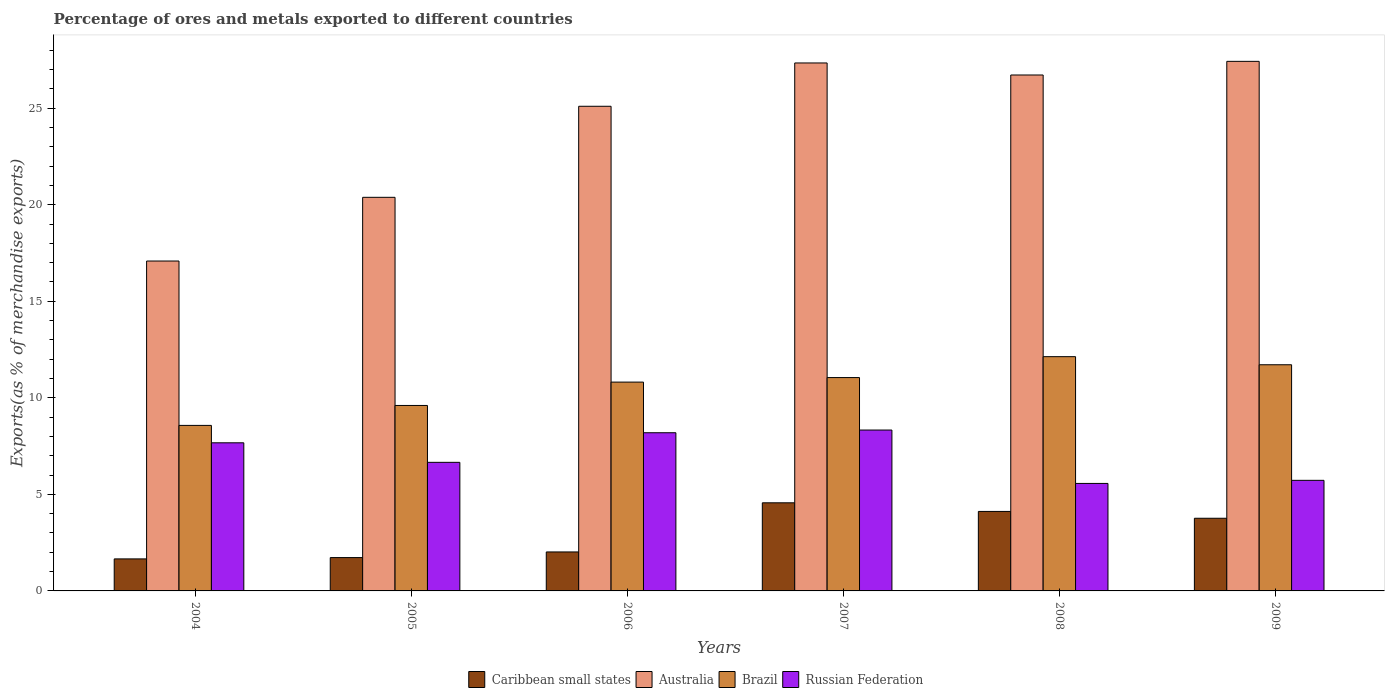How many different coloured bars are there?
Your answer should be compact. 4. Are the number of bars per tick equal to the number of legend labels?
Give a very brief answer. Yes. How many bars are there on the 5th tick from the right?
Ensure brevity in your answer.  4. What is the percentage of exports to different countries in Caribbean small states in 2008?
Make the answer very short. 4.12. Across all years, what is the maximum percentage of exports to different countries in Brazil?
Keep it short and to the point. 12.13. Across all years, what is the minimum percentage of exports to different countries in Russian Federation?
Provide a succinct answer. 5.57. In which year was the percentage of exports to different countries in Caribbean small states maximum?
Your answer should be compact. 2007. What is the total percentage of exports to different countries in Russian Federation in the graph?
Offer a terse response. 42.15. What is the difference between the percentage of exports to different countries in Australia in 2007 and that in 2009?
Your response must be concise. -0.08. What is the difference between the percentage of exports to different countries in Brazil in 2007 and the percentage of exports to different countries in Australia in 2006?
Give a very brief answer. -14.05. What is the average percentage of exports to different countries in Brazil per year?
Provide a short and direct response. 10.65. In the year 2009, what is the difference between the percentage of exports to different countries in Russian Federation and percentage of exports to different countries in Brazil?
Your answer should be very brief. -5.99. What is the ratio of the percentage of exports to different countries in Brazil in 2005 to that in 2007?
Your answer should be very brief. 0.87. Is the percentage of exports to different countries in Brazil in 2004 less than that in 2005?
Ensure brevity in your answer.  Yes. What is the difference between the highest and the second highest percentage of exports to different countries in Brazil?
Provide a short and direct response. 0.42. What is the difference between the highest and the lowest percentage of exports to different countries in Russian Federation?
Keep it short and to the point. 2.77. In how many years, is the percentage of exports to different countries in Caribbean small states greater than the average percentage of exports to different countries in Caribbean small states taken over all years?
Your answer should be very brief. 3. Is it the case that in every year, the sum of the percentage of exports to different countries in Russian Federation and percentage of exports to different countries in Brazil is greater than the sum of percentage of exports to different countries in Australia and percentage of exports to different countries in Caribbean small states?
Your answer should be very brief. No. What does the 1st bar from the left in 2006 represents?
Give a very brief answer. Caribbean small states. What does the 1st bar from the right in 2006 represents?
Give a very brief answer. Russian Federation. How many years are there in the graph?
Keep it short and to the point. 6. How are the legend labels stacked?
Your answer should be compact. Horizontal. What is the title of the graph?
Your answer should be compact. Percentage of ores and metals exported to different countries. What is the label or title of the Y-axis?
Ensure brevity in your answer.  Exports(as % of merchandise exports). What is the Exports(as % of merchandise exports) in Caribbean small states in 2004?
Provide a short and direct response. 1.66. What is the Exports(as % of merchandise exports) of Australia in 2004?
Your answer should be compact. 17.09. What is the Exports(as % of merchandise exports) in Brazil in 2004?
Provide a succinct answer. 8.57. What is the Exports(as % of merchandise exports) of Russian Federation in 2004?
Provide a succinct answer. 7.67. What is the Exports(as % of merchandise exports) in Caribbean small states in 2005?
Give a very brief answer. 1.73. What is the Exports(as % of merchandise exports) of Australia in 2005?
Your answer should be very brief. 20.38. What is the Exports(as % of merchandise exports) in Brazil in 2005?
Give a very brief answer. 9.61. What is the Exports(as % of merchandise exports) in Russian Federation in 2005?
Ensure brevity in your answer.  6.66. What is the Exports(as % of merchandise exports) in Caribbean small states in 2006?
Give a very brief answer. 2.02. What is the Exports(as % of merchandise exports) of Australia in 2006?
Make the answer very short. 25.1. What is the Exports(as % of merchandise exports) of Brazil in 2006?
Your response must be concise. 10.81. What is the Exports(as % of merchandise exports) of Russian Federation in 2006?
Offer a terse response. 8.19. What is the Exports(as % of merchandise exports) of Caribbean small states in 2007?
Offer a terse response. 4.56. What is the Exports(as % of merchandise exports) in Australia in 2007?
Keep it short and to the point. 27.34. What is the Exports(as % of merchandise exports) of Brazil in 2007?
Offer a very short reply. 11.05. What is the Exports(as % of merchandise exports) of Russian Federation in 2007?
Give a very brief answer. 8.33. What is the Exports(as % of merchandise exports) of Caribbean small states in 2008?
Provide a short and direct response. 4.12. What is the Exports(as % of merchandise exports) of Australia in 2008?
Keep it short and to the point. 26.72. What is the Exports(as % of merchandise exports) of Brazil in 2008?
Make the answer very short. 12.13. What is the Exports(as % of merchandise exports) in Russian Federation in 2008?
Provide a short and direct response. 5.57. What is the Exports(as % of merchandise exports) in Caribbean small states in 2009?
Your answer should be compact. 3.76. What is the Exports(as % of merchandise exports) of Australia in 2009?
Keep it short and to the point. 27.43. What is the Exports(as % of merchandise exports) in Brazil in 2009?
Your answer should be very brief. 11.71. What is the Exports(as % of merchandise exports) in Russian Federation in 2009?
Your response must be concise. 5.73. Across all years, what is the maximum Exports(as % of merchandise exports) in Caribbean small states?
Ensure brevity in your answer.  4.56. Across all years, what is the maximum Exports(as % of merchandise exports) in Australia?
Make the answer very short. 27.43. Across all years, what is the maximum Exports(as % of merchandise exports) of Brazil?
Keep it short and to the point. 12.13. Across all years, what is the maximum Exports(as % of merchandise exports) of Russian Federation?
Provide a short and direct response. 8.33. Across all years, what is the minimum Exports(as % of merchandise exports) in Caribbean small states?
Offer a very short reply. 1.66. Across all years, what is the minimum Exports(as % of merchandise exports) in Australia?
Give a very brief answer. 17.09. Across all years, what is the minimum Exports(as % of merchandise exports) of Brazil?
Provide a short and direct response. 8.57. Across all years, what is the minimum Exports(as % of merchandise exports) in Russian Federation?
Offer a terse response. 5.57. What is the total Exports(as % of merchandise exports) of Caribbean small states in the graph?
Give a very brief answer. 17.85. What is the total Exports(as % of merchandise exports) in Australia in the graph?
Ensure brevity in your answer.  144.06. What is the total Exports(as % of merchandise exports) in Brazil in the graph?
Offer a terse response. 63.89. What is the total Exports(as % of merchandise exports) in Russian Federation in the graph?
Provide a succinct answer. 42.15. What is the difference between the Exports(as % of merchandise exports) of Caribbean small states in 2004 and that in 2005?
Provide a succinct answer. -0.07. What is the difference between the Exports(as % of merchandise exports) of Australia in 2004 and that in 2005?
Give a very brief answer. -3.3. What is the difference between the Exports(as % of merchandise exports) of Brazil in 2004 and that in 2005?
Give a very brief answer. -1.03. What is the difference between the Exports(as % of merchandise exports) in Russian Federation in 2004 and that in 2005?
Your response must be concise. 1.01. What is the difference between the Exports(as % of merchandise exports) in Caribbean small states in 2004 and that in 2006?
Your answer should be very brief. -0.36. What is the difference between the Exports(as % of merchandise exports) of Australia in 2004 and that in 2006?
Make the answer very short. -8.01. What is the difference between the Exports(as % of merchandise exports) in Brazil in 2004 and that in 2006?
Your answer should be very brief. -2.24. What is the difference between the Exports(as % of merchandise exports) in Russian Federation in 2004 and that in 2006?
Keep it short and to the point. -0.52. What is the difference between the Exports(as % of merchandise exports) of Caribbean small states in 2004 and that in 2007?
Your response must be concise. -2.9. What is the difference between the Exports(as % of merchandise exports) of Australia in 2004 and that in 2007?
Your answer should be compact. -10.26. What is the difference between the Exports(as % of merchandise exports) in Brazil in 2004 and that in 2007?
Provide a succinct answer. -2.48. What is the difference between the Exports(as % of merchandise exports) of Russian Federation in 2004 and that in 2007?
Your answer should be very brief. -0.66. What is the difference between the Exports(as % of merchandise exports) in Caribbean small states in 2004 and that in 2008?
Provide a short and direct response. -2.46. What is the difference between the Exports(as % of merchandise exports) of Australia in 2004 and that in 2008?
Your answer should be compact. -9.63. What is the difference between the Exports(as % of merchandise exports) of Brazil in 2004 and that in 2008?
Give a very brief answer. -3.56. What is the difference between the Exports(as % of merchandise exports) in Russian Federation in 2004 and that in 2008?
Provide a short and direct response. 2.1. What is the difference between the Exports(as % of merchandise exports) in Caribbean small states in 2004 and that in 2009?
Keep it short and to the point. -2.1. What is the difference between the Exports(as % of merchandise exports) in Australia in 2004 and that in 2009?
Give a very brief answer. -10.34. What is the difference between the Exports(as % of merchandise exports) of Brazil in 2004 and that in 2009?
Your response must be concise. -3.14. What is the difference between the Exports(as % of merchandise exports) in Russian Federation in 2004 and that in 2009?
Offer a terse response. 1.94. What is the difference between the Exports(as % of merchandise exports) in Caribbean small states in 2005 and that in 2006?
Offer a very short reply. -0.29. What is the difference between the Exports(as % of merchandise exports) of Australia in 2005 and that in 2006?
Your answer should be very brief. -4.72. What is the difference between the Exports(as % of merchandise exports) of Brazil in 2005 and that in 2006?
Give a very brief answer. -1.21. What is the difference between the Exports(as % of merchandise exports) in Russian Federation in 2005 and that in 2006?
Make the answer very short. -1.53. What is the difference between the Exports(as % of merchandise exports) in Caribbean small states in 2005 and that in 2007?
Provide a short and direct response. -2.84. What is the difference between the Exports(as % of merchandise exports) of Australia in 2005 and that in 2007?
Make the answer very short. -6.96. What is the difference between the Exports(as % of merchandise exports) in Brazil in 2005 and that in 2007?
Your answer should be compact. -1.44. What is the difference between the Exports(as % of merchandise exports) in Russian Federation in 2005 and that in 2007?
Your answer should be compact. -1.67. What is the difference between the Exports(as % of merchandise exports) of Caribbean small states in 2005 and that in 2008?
Your answer should be very brief. -2.39. What is the difference between the Exports(as % of merchandise exports) in Australia in 2005 and that in 2008?
Give a very brief answer. -6.34. What is the difference between the Exports(as % of merchandise exports) of Brazil in 2005 and that in 2008?
Offer a terse response. -2.53. What is the difference between the Exports(as % of merchandise exports) in Russian Federation in 2005 and that in 2008?
Make the answer very short. 1.09. What is the difference between the Exports(as % of merchandise exports) of Caribbean small states in 2005 and that in 2009?
Provide a succinct answer. -2.04. What is the difference between the Exports(as % of merchandise exports) in Australia in 2005 and that in 2009?
Your response must be concise. -7.04. What is the difference between the Exports(as % of merchandise exports) of Brazil in 2005 and that in 2009?
Keep it short and to the point. -2.11. What is the difference between the Exports(as % of merchandise exports) of Russian Federation in 2005 and that in 2009?
Offer a terse response. 0.93. What is the difference between the Exports(as % of merchandise exports) in Caribbean small states in 2006 and that in 2007?
Provide a succinct answer. -2.54. What is the difference between the Exports(as % of merchandise exports) of Australia in 2006 and that in 2007?
Your answer should be very brief. -2.24. What is the difference between the Exports(as % of merchandise exports) in Brazil in 2006 and that in 2007?
Provide a succinct answer. -0.23. What is the difference between the Exports(as % of merchandise exports) of Russian Federation in 2006 and that in 2007?
Your answer should be very brief. -0.14. What is the difference between the Exports(as % of merchandise exports) of Caribbean small states in 2006 and that in 2008?
Offer a terse response. -2.1. What is the difference between the Exports(as % of merchandise exports) in Australia in 2006 and that in 2008?
Make the answer very short. -1.62. What is the difference between the Exports(as % of merchandise exports) of Brazil in 2006 and that in 2008?
Your answer should be very brief. -1.32. What is the difference between the Exports(as % of merchandise exports) of Russian Federation in 2006 and that in 2008?
Provide a succinct answer. 2.63. What is the difference between the Exports(as % of merchandise exports) in Caribbean small states in 2006 and that in 2009?
Make the answer very short. -1.74. What is the difference between the Exports(as % of merchandise exports) of Australia in 2006 and that in 2009?
Provide a short and direct response. -2.33. What is the difference between the Exports(as % of merchandise exports) in Brazil in 2006 and that in 2009?
Keep it short and to the point. -0.9. What is the difference between the Exports(as % of merchandise exports) in Russian Federation in 2006 and that in 2009?
Offer a very short reply. 2.46. What is the difference between the Exports(as % of merchandise exports) in Caribbean small states in 2007 and that in 2008?
Give a very brief answer. 0.45. What is the difference between the Exports(as % of merchandise exports) in Australia in 2007 and that in 2008?
Your answer should be very brief. 0.62. What is the difference between the Exports(as % of merchandise exports) of Brazil in 2007 and that in 2008?
Make the answer very short. -1.08. What is the difference between the Exports(as % of merchandise exports) in Russian Federation in 2007 and that in 2008?
Your answer should be very brief. 2.77. What is the difference between the Exports(as % of merchandise exports) in Caribbean small states in 2007 and that in 2009?
Make the answer very short. 0.8. What is the difference between the Exports(as % of merchandise exports) in Australia in 2007 and that in 2009?
Your answer should be very brief. -0.08. What is the difference between the Exports(as % of merchandise exports) of Brazil in 2007 and that in 2009?
Provide a short and direct response. -0.66. What is the difference between the Exports(as % of merchandise exports) in Russian Federation in 2007 and that in 2009?
Give a very brief answer. 2.6. What is the difference between the Exports(as % of merchandise exports) in Caribbean small states in 2008 and that in 2009?
Offer a very short reply. 0.35. What is the difference between the Exports(as % of merchandise exports) in Australia in 2008 and that in 2009?
Provide a succinct answer. -0.71. What is the difference between the Exports(as % of merchandise exports) of Brazil in 2008 and that in 2009?
Provide a succinct answer. 0.42. What is the difference between the Exports(as % of merchandise exports) of Russian Federation in 2008 and that in 2009?
Ensure brevity in your answer.  -0.16. What is the difference between the Exports(as % of merchandise exports) in Caribbean small states in 2004 and the Exports(as % of merchandise exports) in Australia in 2005?
Offer a very short reply. -18.73. What is the difference between the Exports(as % of merchandise exports) of Caribbean small states in 2004 and the Exports(as % of merchandise exports) of Brazil in 2005?
Offer a terse response. -7.95. What is the difference between the Exports(as % of merchandise exports) of Caribbean small states in 2004 and the Exports(as % of merchandise exports) of Russian Federation in 2005?
Keep it short and to the point. -5. What is the difference between the Exports(as % of merchandise exports) of Australia in 2004 and the Exports(as % of merchandise exports) of Brazil in 2005?
Your answer should be compact. 7.48. What is the difference between the Exports(as % of merchandise exports) of Australia in 2004 and the Exports(as % of merchandise exports) of Russian Federation in 2005?
Offer a terse response. 10.43. What is the difference between the Exports(as % of merchandise exports) in Brazil in 2004 and the Exports(as % of merchandise exports) in Russian Federation in 2005?
Your answer should be very brief. 1.91. What is the difference between the Exports(as % of merchandise exports) of Caribbean small states in 2004 and the Exports(as % of merchandise exports) of Australia in 2006?
Provide a short and direct response. -23.44. What is the difference between the Exports(as % of merchandise exports) of Caribbean small states in 2004 and the Exports(as % of merchandise exports) of Brazil in 2006?
Your response must be concise. -9.16. What is the difference between the Exports(as % of merchandise exports) of Caribbean small states in 2004 and the Exports(as % of merchandise exports) of Russian Federation in 2006?
Your response must be concise. -6.53. What is the difference between the Exports(as % of merchandise exports) in Australia in 2004 and the Exports(as % of merchandise exports) in Brazil in 2006?
Offer a terse response. 6.27. What is the difference between the Exports(as % of merchandise exports) of Australia in 2004 and the Exports(as % of merchandise exports) of Russian Federation in 2006?
Provide a succinct answer. 8.89. What is the difference between the Exports(as % of merchandise exports) of Brazil in 2004 and the Exports(as % of merchandise exports) of Russian Federation in 2006?
Your answer should be compact. 0.38. What is the difference between the Exports(as % of merchandise exports) of Caribbean small states in 2004 and the Exports(as % of merchandise exports) of Australia in 2007?
Keep it short and to the point. -25.68. What is the difference between the Exports(as % of merchandise exports) of Caribbean small states in 2004 and the Exports(as % of merchandise exports) of Brazil in 2007?
Keep it short and to the point. -9.39. What is the difference between the Exports(as % of merchandise exports) of Caribbean small states in 2004 and the Exports(as % of merchandise exports) of Russian Federation in 2007?
Your answer should be compact. -6.67. What is the difference between the Exports(as % of merchandise exports) of Australia in 2004 and the Exports(as % of merchandise exports) of Brazil in 2007?
Your answer should be compact. 6.04. What is the difference between the Exports(as % of merchandise exports) of Australia in 2004 and the Exports(as % of merchandise exports) of Russian Federation in 2007?
Your answer should be compact. 8.75. What is the difference between the Exports(as % of merchandise exports) of Brazil in 2004 and the Exports(as % of merchandise exports) of Russian Federation in 2007?
Ensure brevity in your answer.  0.24. What is the difference between the Exports(as % of merchandise exports) in Caribbean small states in 2004 and the Exports(as % of merchandise exports) in Australia in 2008?
Your answer should be very brief. -25.06. What is the difference between the Exports(as % of merchandise exports) of Caribbean small states in 2004 and the Exports(as % of merchandise exports) of Brazil in 2008?
Your answer should be compact. -10.47. What is the difference between the Exports(as % of merchandise exports) of Caribbean small states in 2004 and the Exports(as % of merchandise exports) of Russian Federation in 2008?
Give a very brief answer. -3.91. What is the difference between the Exports(as % of merchandise exports) in Australia in 2004 and the Exports(as % of merchandise exports) in Brazil in 2008?
Your answer should be very brief. 4.95. What is the difference between the Exports(as % of merchandise exports) of Australia in 2004 and the Exports(as % of merchandise exports) of Russian Federation in 2008?
Provide a succinct answer. 11.52. What is the difference between the Exports(as % of merchandise exports) of Brazil in 2004 and the Exports(as % of merchandise exports) of Russian Federation in 2008?
Keep it short and to the point. 3.01. What is the difference between the Exports(as % of merchandise exports) of Caribbean small states in 2004 and the Exports(as % of merchandise exports) of Australia in 2009?
Make the answer very short. -25.77. What is the difference between the Exports(as % of merchandise exports) in Caribbean small states in 2004 and the Exports(as % of merchandise exports) in Brazil in 2009?
Your answer should be compact. -10.05. What is the difference between the Exports(as % of merchandise exports) of Caribbean small states in 2004 and the Exports(as % of merchandise exports) of Russian Federation in 2009?
Your response must be concise. -4.07. What is the difference between the Exports(as % of merchandise exports) of Australia in 2004 and the Exports(as % of merchandise exports) of Brazil in 2009?
Make the answer very short. 5.37. What is the difference between the Exports(as % of merchandise exports) of Australia in 2004 and the Exports(as % of merchandise exports) of Russian Federation in 2009?
Keep it short and to the point. 11.36. What is the difference between the Exports(as % of merchandise exports) of Brazil in 2004 and the Exports(as % of merchandise exports) of Russian Federation in 2009?
Offer a very short reply. 2.85. What is the difference between the Exports(as % of merchandise exports) of Caribbean small states in 2005 and the Exports(as % of merchandise exports) of Australia in 2006?
Provide a succinct answer. -23.37. What is the difference between the Exports(as % of merchandise exports) of Caribbean small states in 2005 and the Exports(as % of merchandise exports) of Brazil in 2006?
Offer a terse response. -9.09. What is the difference between the Exports(as % of merchandise exports) in Caribbean small states in 2005 and the Exports(as % of merchandise exports) in Russian Federation in 2006?
Provide a succinct answer. -6.47. What is the difference between the Exports(as % of merchandise exports) in Australia in 2005 and the Exports(as % of merchandise exports) in Brazil in 2006?
Offer a terse response. 9.57. What is the difference between the Exports(as % of merchandise exports) in Australia in 2005 and the Exports(as % of merchandise exports) in Russian Federation in 2006?
Provide a succinct answer. 12.19. What is the difference between the Exports(as % of merchandise exports) of Brazil in 2005 and the Exports(as % of merchandise exports) of Russian Federation in 2006?
Provide a short and direct response. 1.41. What is the difference between the Exports(as % of merchandise exports) in Caribbean small states in 2005 and the Exports(as % of merchandise exports) in Australia in 2007?
Ensure brevity in your answer.  -25.62. What is the difference between the Exports(as % of merchandise exports) of Caribbean small states in 2005 and the Exports(as % of merchandise exports) of Brazil in 2007?
Give a very brief answer. -9.32. What is the difference between the Exports(as % of merchandise exports) of Caribbean small states in 2005 and the Exports(as % of merchandise exports) of Russian Federation in 2007?
Ensure brevity in your answer.  -6.61. What is the difference between the Exports(as % of merchandise exports) of Australia in 2005 and the Exports(as % of merchandise exports) of Brazil in 2007?
Give a very brief answer. 9.34. What is the difference between the Exports(as % of merchandise exports) of Australia in 2005 and the Exports(as % of merchandise exports) of Russian Federation in 2007?
Ensure brevity in your answer.  12.05. What is the difference between the Exports(as % of merchandise exports) in Brazil in 2005 and the Exports(as % of merchandise exports) in Russian Federation in 2007?
Make the answer very short. 1.27. What is the difference between the Exports(as % of merchandise exports) in Caribbean small states in 2005 and the Exports(as % of merchandise exports) in Australia in 2008?
Offer a terse response. -24.99. What is the difference between the Exports(as % of merchandise exports) of Caribbean small states in 2005 and the Exports(as % of merchandise exports) of Brazil in 2008?
Offer a very short reply. -10.41. What is the difference between the Exports(as % of merchandise exports) of Caribbean small states in 2005 and the Exports(as % of merchandise exports) of Russian Federation in 2008?
Your answer should be compact. -3.84. What is the difference between the Exports(as % of merchandise exports) in Australia in 2005 and the Exports(as % of merchandise exports) in Brazil in 2008?
Keep it short and to the point. 8.25. What is the difference between the Exports(as % of merchandise exports) of Australia in 2005 and the Exports(as % of merchandise exports) of Russian Federation in 2008?
Offer a very short reply. 14.82. What is the difference between the Exports(as % of merchandise exports) of Brazil in 2005 and the Exports(as % of merchandise exports) of Russian Federation in 2008?
Ensure brevity in your answer.  4.04. What is the difference between the Exports(as % of merchandise exports) in Caribbean small states in 2005 and the Exports(as % of merchandise exports) in Australia in 2009?
Offer a very short reply. -25.7. What is the difference between the Exports(as % of merchandise exports) in Caribbean small states in 2005 and the Exports(as % of merchandise exports) in Brazil in 2009?
Your response must be concise. -9.99. What is the difference between the Exports(as % of merchandise exports) of Caribbean small states in 2005 and the Exports(as % of merchandise exports) of Russian Federation in 2009?
Your answer should be very brief. -4. What is the difference between the Exports(as % of merchandise exports) of Australia in 2005 and the Exports(as % of merchandise exports) of Brazil in 2009?
Keep it short and to the point. 8.67. What is the difference between the Exports(as % of merchandise exports) in Australia in 2005 and the Exports(as % of merchandise exports) in Russian Federation in 2009?
Ensure brevity in your answer.  14.66. What is the difference between the Exports(as % of merchandise exports) in Brazil in 2005 and the Exports(as % of merchandise exports) in Russian Federation in 2009?
Your response must be concise. 3.88. What is the difference between the Exports(as % of merchandise exports) in Caribbean small states in 2006 and the Exports(as % of merchandise exports) in Australia in 2007?
Keep it short and to the point. -25.32. What is the difference between the Exports(as % of merchandise exports) of Caribbean small states in 2006 and the Exports(as % of merchandise exports) of Brazil in 2007?
Your answer should be compact. -9.03. What is the difference between the Exports(as % of merchandise exports) of Caribbean small states in 2006 and the Exports(as % of merchandise exports) of Russian Federation in 2007?
Your response must be concise. -6.31. What is the difference between the Exports(as % of merchandise exports) in Australia in 2006 and the Exports(as % of merchandise exports) in Brazil in 2007?
Offer a very short reply. 14.05. What is the difference between the Exports(as % of merchandise exports) of Australia in 2006 and the Exports(as % of merchandise exports) of Russian Federation in 2007?
Provide a succinct answer. 16.77. What is the difference between the Exports(as % of merchandise exports) of Brazil in 2006 and the Exports(as % of merchandise exports) of Russian Federation in 2007?
Your answer should be very brief. 2.48. What is the difference between the Exports(as % of merchandise exports) of Caribbean small states in 2006 and the Exports(as % of merchandise exports) of Australia in 2008?
Your answer should be compact. -24.7. What is the difference between the Exports(as % of merchandise exports) in Caribbean small states in 2006 and the Exports(as % of merchandise exports) in Brazil in 2008?
Your answer should be compact. -10.11. What is the difference between the Exports(as % of merchandise exports) in Caribbean small states in 2006 and the Exports(as % of merchandise exports) in Russian Federation in 2008?
Provide a succinct answer. -3.55. What is the difference between the Exports(as % of merchandise exports) of Australia in 2006 and the Exports(as % of merchandise exports) of Brazil in 2008?
Give a very brief answer. 12.97. What is the difference between the Exports(as % of merchandise exports) of Australia in 2006 and the Exports(as % of merchandise exports) of Russian Federation in 2008?
Ensure brevity in your answer.  19.53. What is the difference between the Exports(as % of merchandise exports) of Brazil in 2006 and the Exports(as % of merchandise exports) of Russian Federation in 2008?
Provide a succinct answer. 5.25. What is the difference between the Exports(as % of merchandise exports) in Caribbean small states in 2006 and the Exports(as % of merchandise exports) in Australia in 2009?
Your answer should be compact. -25.41. What is the difference between the Exports(as % of merchandise exports) in Caribbean small states in 2006 and the Exports(as % of merchandise exports) in Brazil in 2009?
Your answer should be compact. -9.69. What is the difference between the Exports(as % of merchandise exports) in Caribbean small states in 2006 and the Exports(as % of merchandise exports) in Russian Federation in 2009?
Offer a terse response. -3.71. What is the difference between the Exports(as % of merchandise exports) in Australia in 2006 and the Exports(as % of merchandise exports) in Brazil in 2009?
Ensure brevity in your answer.  13.39. What is the difference between the Exports(as % of merchandise exports) of Australia in 2006 and the Exports(as % of merchandise exports) of Russian Federation in 2009?
Make the answer very short. 19.37. What is the difference between the Exports(as % of merchandise exports) of Brazil in 2006 and the Exports(as % of merchandise exports) of Russian Federation in 2009?
Your answer should be compact. 5.09. What is the difference between the Exports(as % of merchandise exports) of Caribbean small states in 2007 and the Exports(as % of merchandise exports) of Australia in 2008?
Offer a very short reply. -22.16. What is the difference between the Exports(as % of merchandise exports) in Caribbean small states in 2007 and the Exports(as % of merchandise exports) in Brazil in 2008?
Give a very brief answer. -7.57. What is the difference between the Exports(as % of merchandise exports) in Caribbean small states in 2007 and the Exports(as % of merchandise exports) in Russian Federation in 2008?
Offer a very short reply. -1. What is the difference between the Exports(as % of merchandise exports) of Australia in 2007 and the Exports(as % of merchandise exports) of Brazil in 2008?
Your response must be concise. 15.21. What is the difference between the Exports(as % of merchandise exports) in Australia in 2007 and the Exports(as % of merchandise exports) in Russian Federation in 2008?
Make the answer very short. 21.78. What is the difference between the Exports(as % of merchandise exports) in Brazil in 2007 and the Exports(as % of merchandise exports) in Russian Federation in 2008?
Offer a terse response. 5.48. What is the difference between the Exports(as % of merchandise exports) of Caribbean small states in 2007 and the Exports(as % of merchandise exports) of Australia in 2009?
Keep it short and to the point. -22.86. What is the difference between the Exports(as % of merchandise exports) in Caribbean small states in 2007 and the Exports(as % of merchandise exports) in Brazil in 2009?
Make the answer very short. -7.15. What is the difference between the Exports(as % of merchandise exports) of Caribbean small states in 2007 and the Exports(as % of merchandise exports) of Russian Federation in 2009?
Give a very brief answer. -1.16. What is the difference between the Exports(as % of merchandise exports) of Australia in 2007 and the Exports(as % of merchandise exports) of Brazil in 2009?
Ensure brevity in your answer.  15.63. What is the difference between the Exports(as % of merchandise exports) of Australia in 2007 and the Exports(as % of merchandise exports) of Russian Federation in 2009?
Offer a very short reply. 21.62. What is the difference between the Exports(as % of merchandise exports) of Brazil in 2007 and the Exports(as % of merchandise exports) of Russian Federation in 2009?
Offer a very short reply. 5.32. What is the difference between the Exports(as % of merchandise exports) in Caribbean small states in 2008 and the Exports(as % of merchandise exports) in Australia in 2009?
Ensure brevity in your answer.  -23.31. What is the difference between the Exports(as % of merchandise exports) of Caribbean small states in 2008 and the Exports(as % of merchandise exports) of Brazil in 2009?
Provide a short and direct response. -7.6. What is the difference between the Exports(as % of merchandise exports) of Caribbean small states in 2008 and the Exports(as % of merchandise exports) of Russian Federation in 2009?
Offer a very short reply. -1.61. What is the difference between the Exports(as % of merchandise exports) of Australia in 2008 and the Exports(as % of merchandise exports) of Brazil in 2009?
Provide a succinct answer. 15.01. What is the difference between the Exports(as % of merchandise exports) in Australia in 2008 and the Exports(as % of merchandise exports) in Russian Federation in 2009?
Your answer should be compact. 20.99. What is the difference between the Exports(as % of merchandise exports) in Brazil in 2008 and the Exports(as % of merchandise exports) in Russian Federation in 2009?
Make the answer very short. 6.4. What is the average Exports(as % of merchandise exports) in Caribbean small states per year?
Make the answer very short. 2.97. What is the average Exports(as % of merchandise exports) of Australia per year?
Offer a terse response. 24.01. What is the average Exports(as % of merchandise exports) of Brazil per year?
Your answer should be compact. 10.65. What is the average Exports(as % of merchandise exports) of Russian Federation per year?
Your answer should be compact. 7.03. In the year 2004, what is the difference between the Exports(as % of merchandise exports) in Caribbean small states and Exports(as % of merchandise exports) in Australia?
Ensure brevity in your answer.  -15.43. In the year 2004, what is the difference between the Exports(as % of merchandise exports) in Caribbean small states and Exports(as % of merchandise exports) in Brazil?
Offer a terse response. -6.91. In the year 2004, what is the difference between the Exports(as % of merchandise exports) in Caribbean small states and Exports(as % of merchandise exports) in Russian Federation?
Provide a short and direct response. -6.01. In the year 2004, what is the difference between the Exports(as % of merchandise exports) of Australia and Exports(as % of merchandise exports) of Brazil?
Provide a short and direct response. 8.51. In the year 2004, what is the difference between the Exports(as % of merchandise exports) in Australia and Exports(as % of merchandise exports) in Russian Federation?
Offer a terse response. 9.41. In the year 2004, what is the difference between the Exports(as % of merchandise exports) of Brazil and Exports(as % of merchandise exports) of Russian Federation?
Make the answer very short. 0.9. In the year 2005, what is the difference between the Exports(as % of merchandise exports) of Caribbean small states and Exports(as % of merchandise exports) of Australia?
Your answer should be compact. -18.66. In the year 2005, what is the difference between the Exports(as % of merchandise exports) in Caribbean small states and Exports(as % of merchandise exports) in Brazil?
Keep it short and to the point. -7.88. In the year 2005, what is the difference between the Exports(as % of merchandise exports) in Caribbean small states and Exports(as % of merchandise exports) in Russian Federation?
Offer a very short reply. -4.93. In the year 2005, what is the difference between the Exports(as % of merchandise exports) of Australia and Exports(as % of merchandise exports) of Brazil?
Your answer should be compact. 10.78. In the year 2005, what is the difference between the Exports(as % of merchandise exports) of Australia and Exports(as % of merchandise exports) of Russian Federation?
Provide a succinct answer. 13.73. In the year 2005, what is the difference between the Exports(as % of merchandise exports) of Brazil and Exports(as % of merchandise exports) of Russian Federation?
Your answer should be compact. 2.95. In the year 2006, what is the difference between the Exports(as % of merchandise exports) in Caribbean small states and Exports(as % of merchandise exports) in Australia?
Your answer should be compact. -23.08. In the year 2006, what is the difference between the Exports(as % of merchandise exports) in Caribbean small states and Exports(as % of merchandise exports) in Brazil?
Provide a succinct answer. -8.8. In the year 2006, what is the difference between the Exports(as % of merchandise exports) in Caribbean small states and Exports(as % of merchandise exports) in Russian Federation?
Offer a terse response. -6.17. In the year 2006, what is the difference between the Exports(as % of merchandise exports) in Australia and Exports(as % of merchandise exports) in Brazil?
Give a very brief answer. 14.29. In the year 2006, what is the difference between the Exports(as % of merchandise exports) of Australia and Exports(as % of merchandise exports) of Russian Federation?
Offer a terse response. 16.91. In the year 2006, what is the difference between the Exports(as % of merchandise exports) of Brazil and Exports(as % of merchandise exports) of Russian Federation?
Give a very brief answer. 2.62. In the year 2007, what is the difference between the Exports(as % of merchandise exports) of Caribbean small states and Exports(as % of merchandise exports) of Australia?
Provide a short and direct response. -22.78. In the year 2007, what is the difference between the Exports(as % of merchandise exports) in Caribbean small states and Exports(as % of merchandise exports) in Brazil?
Make the answer very short. -6.49. In the year 2007, what is the difference between the Exports(as % of merchandise exports) of Caribbean small states and Exports(as % of merchandise exports) of Russian Federation?
Offer a terse response. -3.77. In the year 2007, what is the difference between the Exports(as % of merchandise exports) of Australia and Exports(as % of merchandise exports) of Brazil?
Provide a short and direct response. 16.29. In the year 2007, what is the difference between the Exports(as % of merchandise exports) of Australia and Exports(as % of merchandise exports) of Russian Federation?
Provide a short and direct response. 19.01. In the year 2007, what is the difference between the Exports(as % of merchandise exports) in Brazil and Exports(as % of merchandise exports) in Russian Federation?
Your response must be concise. 2.72. In the year 2008, what is the difference between the Exports(as % of merchandise exports) of Caribbean small states and Exports(as % of merchandise exports) of Australia?
Your answer should be very brief. -22.6. In the year 2008, what is the difference between the Exports(as % of merchandise exports) of Caribbean small states and Exports(as % of merchandise exports) of Brazil?
Provide a short and direct response. -8.02. In the year 2008, what is the difference between the Exports(as % of merchandise exports) of Caribbean small states and Exports(as % of merchandise exports) of Russian Federation?
Keep it short and to the point. -1.45. In the year 2008, what is the difference between the Exports(as % of merchandise exports) in Australia and Exports(as % of merchandise exports) in Brazil?
Give a very brief answer. 14.59. In the year 2008, what is the difference between the Exports(as % of merchandise exports) in Australia and Exports(as % of merchandise exports) in Russian Federation?
Keep it short and to the point. 21.15. In the year 2008, what is the difference between the Exports(as % of merchandise exports) of Brazil and Exports(as % of merchandise exports) of Russian Federation?
Make the answer very short. 6.57. In the year 2009, what is the difference between the Exports(as % of merchandise exports) of Caribbean small states and Exports(as % of merchandise exports) of Australia?
Keep it short and to the point. -23.66. In the year 2009, what is the difference between the Exports(as % of merchandise exports) in Caribbean small states and Exports(as % of merchandise exports) in Brazil?
Offer a very short reply. -7.95. In the year 2009, what is the difference between the Exports(as % of merchandise exports) of Caribbean small states and Exports(as % of merchandise exports) of Russian Federation?
Keep it short and to the point. -1.96. In the year 2009, what is the difference between the Exports(as % of merchandise exports) of Australia and Exports(as % of merchandise exports) of Brazil?
Provide a succinct answer. 15.71. In the year 2009, what is the difference between the Exports(as % of merchandise exports) in Australia and Exports(as % of merchandise exports) in Russian Federation?
Keep it short and to the point. 21.7. In the year 2009, what is the difference between the Exports(as % of merchandise exports) in Brazil and Exports(as % of merchandise exports) in Russian Federation?
Your answer should be compact. 5.99. What is the ratio of the Exports(as % of merchandise exports) of Caribbean small states in 2004 to that in 2005?
Offer a very short reply. 0.96. What is the ratio of the Exports(as % of merchandise exports) of Australia in 2004 to that in 2005?
Your answer should be very brief. 0.84. What is the ratio of the Exports(as % of merchandise exports) in Brazil in 2004 to that in 2005?
Ensure brevity in your answer.  0.89. What is the ratio of the Exports(as % of merchandise exports) in Russian Federation in 2004 to that in 2005?
Your answer should be very brief. 1.15. What is the ratio of the Exports(as % of merchandise exports) of Caribbean small states in 2004 to that in 2006?
Your answer should be compact. 0.82. What is the ratio of the Exports(as % of merchandise exports) in Australia in 2004 to that in 2006?
Your response must be concise. 0.68. What is the ratio of the Exports(as % of merchandise exports) in Brazil in 2004 to that in 2006?
Offer a very short reply. 0.79. What is the ratio of the Exports(as % of merchandise exports) of Russian Federation in 2004 to that in 2006?
Your answer should be compact. 0.94. What is the ratio of the Exports(as % of merchandise exports) of Caribbean small states in 2004 to that in 2007?
Provide a short and direct response. 0.36. What is the ratio of the Exports(as % of merchandise exports) of Australia in 2004 to that in 2007?
Make the answer very short. 0.62. What is the ratio of the Exports(as % of merchandise exports) of Brazil in 2004 to that in 2007?
Your response must be concise. 0.78. What is the ratio of the Exports(as % of merchandise exports) of Russian Federation in 2004 to that in 2007?
Ensure brevity in your answer.  0.92. What is the ratio of the Exports(as % of merchandise exports) in Caribbean small states in 2004 to that in 2008?
Offer a terse response. 0.4. What is the ratio of the Exports(as % of merchandise exports) of Australia in 2004 to that in 2008?
Your response must be concise. 0.64. What is the ratio of the Exports(as % of merchandise exports) of Brazil in 2004 to that in 2008?
Your answer should be compact. 0.71. What is the ratio of the Exports(as % of merchandise exports) in Russian Federation in 2004 to that in 2008?
Offer a terse response. 1.38. What is the ratio of the Exports(as % of merchandise exports) in Caribbean small states in 2004 to that in 2009?
Ensure brevity in your answer.  0.44. What is the ratio of the Exports(as % of merchandise exports) of Australia in 2004 to that in 2009?
Give a very brief answer. 0.62. What is the ratio of the Exports(as % of merchandise exports) of Brazil in 2004 to that in 2009?
Your answer should be very brief. 0.73. What is the ratio of the Exports(as % of merchandise exports) of Russian Federation in 2004 to that in 2009?
Give a very brief answer. 1.34. What is the ratio of the Exports(as % of merchandise exports) of Caribbean small states in 2005 to that in 2006?
Offer a very short reply. 0.86. What is the ratio of the Exports(as % of merchandise exports) of Australia in 2005 to that in 2006?
Offer a very short reply. 0.81. What is the ratio of the Exports(as % of merchandise exports) of Brazil in 2005 to that in 2006?
Your answer should be compact. 0.89. What is the ratio of the Exports(as % of merchandise exports) in Russian Federation in 2005 to that in 2006?
Offer a terse response. 0.81. What is the ratio of the Exports(as % of merchandise exports) of Caribbean small states in 2005 to that in 2007?
Offer a terse response. 0.38. What is the ratio of the Exports(as % of merchandise exports) of Australia in 2005 to that in 2007?
Make the answer very short. 0.75. What is the ratio of the Exports(as % of merchandise exports) of Brazil in 2005 to that in 2007?
Offer a terse response. 0.87. What is the ratio of the Exports(as % of merchandise exports) in Russian Federation in 2005 to that in 2007?
Offer a very short reply. 0.8. What is the ratio of the Exports(as % of merchandise exports) in Caribbean small states in 2005 to that in 2008?
Ensure brevity in your answer.  0.42. What is the ratio of the Exports(as % of merchandise exports) in Australia in 2005 to that in 2008?
Your response must be concise. 0.76. What is the ratio of the Exports(as % of merchandise exports) in Brazil in 2005 to that in 2008?
Provide a short and direct response. 0.79. What is the ratio of the Exports(as % of merchandise exports) in Russian Federation in 2005 to that in 2008?
Your answer should be very brief. 1.2. What is the ratio of the Exports(as % of merchandise exports) of Caribbean small states in 2005 to that in 2009?
Offer a very short reply. 0.46. What is the ratio of the Exports(as % of merchandise exports) in Australia in 2005 to that in 2009?
Ensure brevity in your answer.  0.74. What is the ratio of the Exports(as % of merchandise exports) of Brazil in 2005 to that in 2009?
Your answer should be very brief. 0.82. What is the ratio of the Exports(as % of merchandise exports) in Russian Federation in 2005 to that in 2009?
Give a very brief answer. 1.16. What is the ratio of the Exports(as % of merchandise exports) of Caribbean small states in 2006 to that in 2007?
Your response must be concise. 0.44. What is the ratio of the Exports(as % of merchandise exports) in Australia in 2006 to that in 2007?
Your answer should be very brief. 0.92. What is the ratio of the Exports(as % of merchandise exports) in Brazil in 2006 to that in 2007?
Your response must be concise. 0.98. What is the ratio of the Exports(as % of merchandise exports) of Russian Federation in 2006 to that in 2007?
Make the answer very short. 0.98. What is the ratio of the Exports(as % of merchandise exports) of Caribbean small states in 2006 to that in 2008?
Your answer should be compact. 0.49. What is the ratio of the Exports(as % of merchandise exports) of Australia in 2006 to that in 2008?
Keep it short and to the point. 0.94. What is the ratio of the Exports(as % of merchandise exports) of Brazil in 2006 to that in 2008?
Ensure brevity in your answer.  0.89. What is the ratio of the Exports(as % of merchandise exports) in Russian Federation in 2006 to that in 2008?
Offer a terse response. 1.47. What is the ratio of the Exports(as % of merchandise exports) of Caribbean small states in 2006 to that in 2009?
Your answer should be compact. 0.54. What is the ratio of the Exports(as % of merchandise exports) of Australia in 2006 to that in 2009?
Your answer should be very brief. 0.92. What is the ratio of the Exports(as % of merchandise exports) of Brazil in 2006 to that in 2009?
Offer a terse response. 0.92. What is the ratio of the Exports(as % of merchandise exports) of Russian Federation in 2006 to that in 2009?
Make the answer very short. 1.43. What is the ratio of the Exports(as % of merchandise exports) of Caribbean small states in 2007 to that in 2008?
Keep it short and to the point. 1.11. What is the ratio of the Exports(as % of merchandise exports) of Australia in 2007 to that in 2008?
Provide a short and direct response. 1.02. What is the ratio of the Exports(as % of merchandise exports) in Brazil in 2007 to that in 2008?
Your answer should be very brief. 0.91. What is the ratio of the Exports(as % of merchandise exports) of Russian Federation in 2007 to that in 2008?
Provide a succinct answer. 1.5. What is the ratio of the Exports(as % of merchandise exports) in Caribbean small states in 2007 to that in 2009?
Your response must be concise. 1.21. What is the ratio of the Exports(as % of merchandise exports) of Australia in 2007 to that in 2009?
Your answer should be very brief. 1. What is the ratio of the Exports(as % of merchandise exports) of Brazil in 2007 to that in 2009?
Provide a short and direct response. 0.94. What is the ratio of the Exports(as % of merchandise exports) of Russian Federation in 2007 to that in 2009?
Ensure brevity in your answer.  1.45. What is the ratio of the Exports(as % of merchandise exports) in Caribbean small states in 2008 to that in 2009?
Your response must be concise. 1.09. What is the ratio of the Exports(as % of merchandise exports) of Australia in 2008 to that in 2009?
Ensure brevity in your answer.  0.97. What is the ratio of the Exports(as % of merchandise exports) in Brazil in 2008 to that in 2009?
Provide a succinct answer. 1.04. What is the difference between the highest and the second highest Exports(as % of merchandise exports) in Caribbean small states?
Provide a succinct answer. 0.45. What is the difference between the highest and the second highest Exports(as % of merchandise exports) of Australia?
Provide a succinct answer. 0.08. What is the difference between the highest and the second highest Exports(as % of merchandise exports) in Brazil?
Offer a very short reply. 0.42. What is the difference between the highest and the second highest Exports(as % of merchandise exports) in Russian Federation?
Your answer should be very brief. 0.14. What is the difference between the highest and the lowest Exports(as % of merchandise exports) of Caribbean small states?
Offer a terse response. 2.9. What is the difference between the highest and the lowest Exports(as % of merchandise exports) of Australia?
Your answer should be compact. 10.34. What is the difference between the highest and the lowest Exports(as % of merchandise exports) in Brazil?
Provide a short and direct response. 3.56. What is the difference between the highest and the lowest Exports(as % of merchandise exports) in Russian Federation?
Offer a terse response. 2.77. 